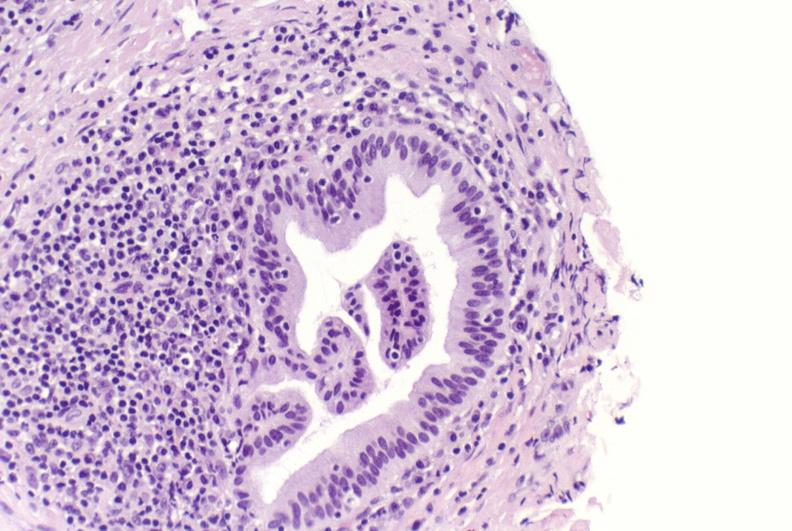s liver present?
Answer the question using a single word or phrase. Yes 